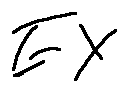<formula> <loc_0><loc_0><loc_500><loc_500>E X</formula> 